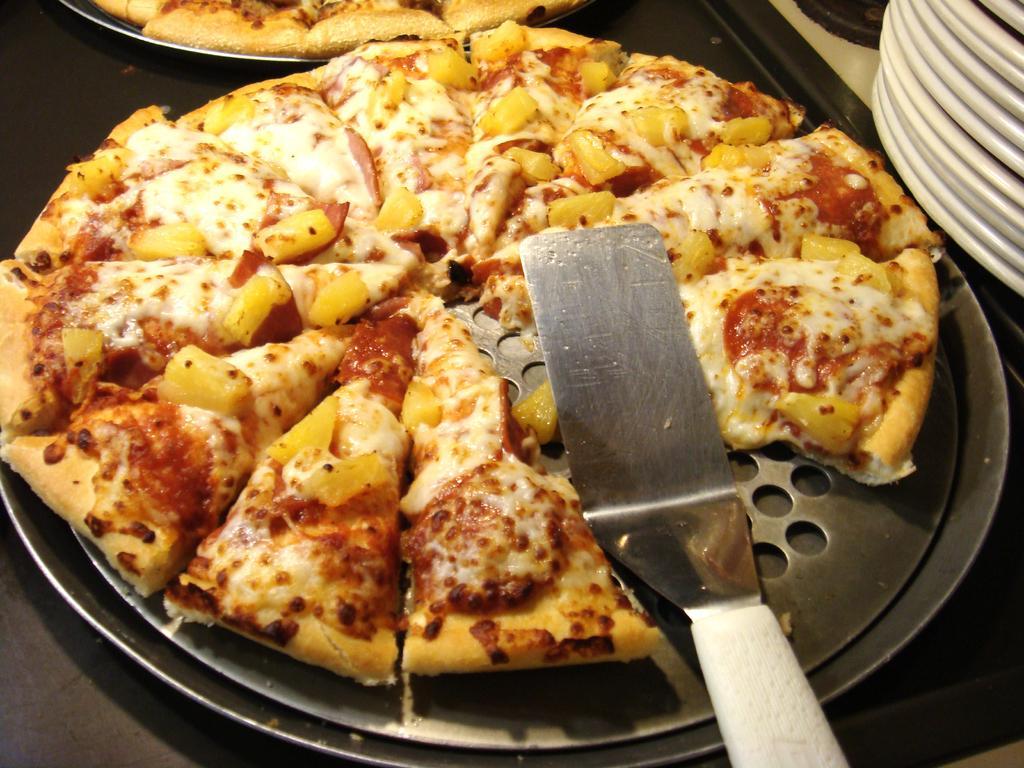In one or two sentences, can you explain what this image depicts? In this image I can see two pizzas on the pans which are placed on a table. Beside this there are few bowls. On the pizza there is a spoon. 